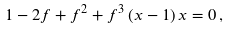Convert formula to latex. <formula><loc_0><loc_0><loc_500><loc_500>1 - 2 f + f ^ { 2 } + f ^ { 3 } \, ( x - 1 ) \, x = 0 \, ,</formula> 